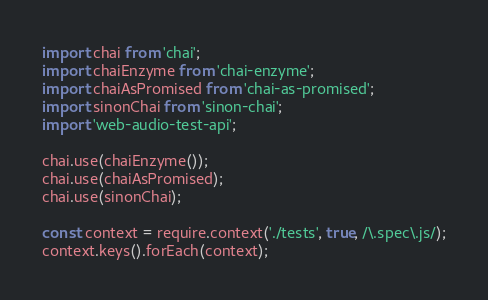<code> <loc_0><loc_0><loc_500><loc_500><_JavaScript_>import chai from 'chai';
import chaiEnzyme from 'chai-enzyme';
import chaiAsPromised from 'chai-as-promised';
import sinonChai from 'sinon-chai';
import 'web-audio-test-api';

chai.use(chaiEnzyme());
chai.use(chaiAsPromised);
chai.use(sinonChai);

const context = require.context('./tests', true, /\.spec\.js/);
context.keys().forEach(context);
</code> 